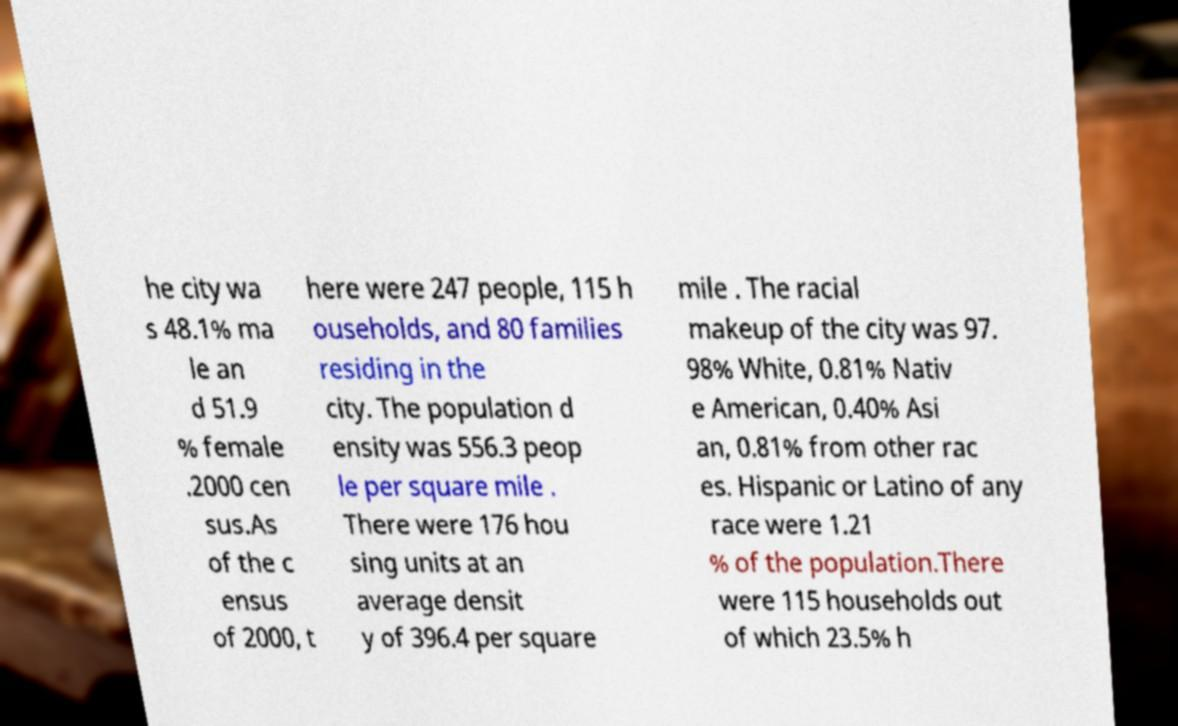Can you read and provide the text displayed in the image?This photo seems to have some interesting text. Can you extract and type it out for me? he city wa s 48.1% ma le an d 51.9 % female .2000 cen sus.As of the c ensus of 2000, t here were 247 people, 115 h ouseholds, and 80 families residing in the city. The population d ensity was 556.3 peop le per square mile . There were 176 hou sing units at an average densit y of 396.4 per square mile . The racial makeup of the city was 97. 98% White, 0.81% Nativ e American, 0.40% Asi an, 0.81% from other rac es. Hispanic or Latino of any race were 1.21 % of the population.There were 115 households out of which 23.5% h 